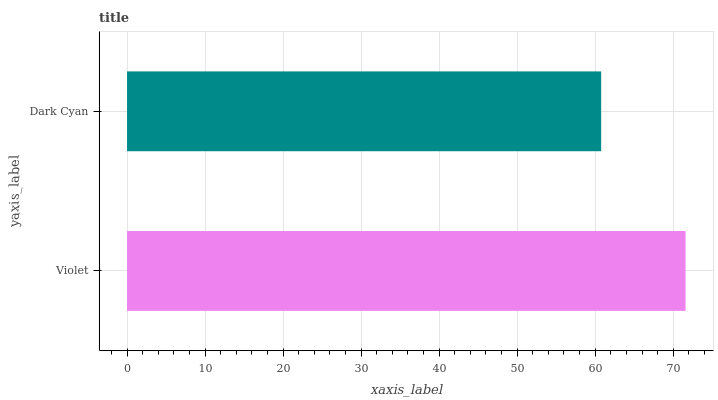Is Dark Cyan the minimum?
Answer yes or no. Yes. Is Violet the maximum?
Answer yes or no. Yes. Is Dark Cyan the maximum?
Answer yes or no. No. Is Violet greater than Dark Cyan?
Answer yes or no. Yes. Is Dark Cyan less than Violet?
Answer yes or no. Yes. Is Dark Cyan greater than Violet?
Answer yes or no. No. Is Violet less than Dark Cyan?
Answer yes or no. No. Is Violet the high median?
Answer yes or no. Yes. Is Dark Cyan the low median?
Answer yes or no. Yes. Is Dark Cyan the high median?
Answer yes or no. No. Is Violet the low median?
Answer yes or no. No. 